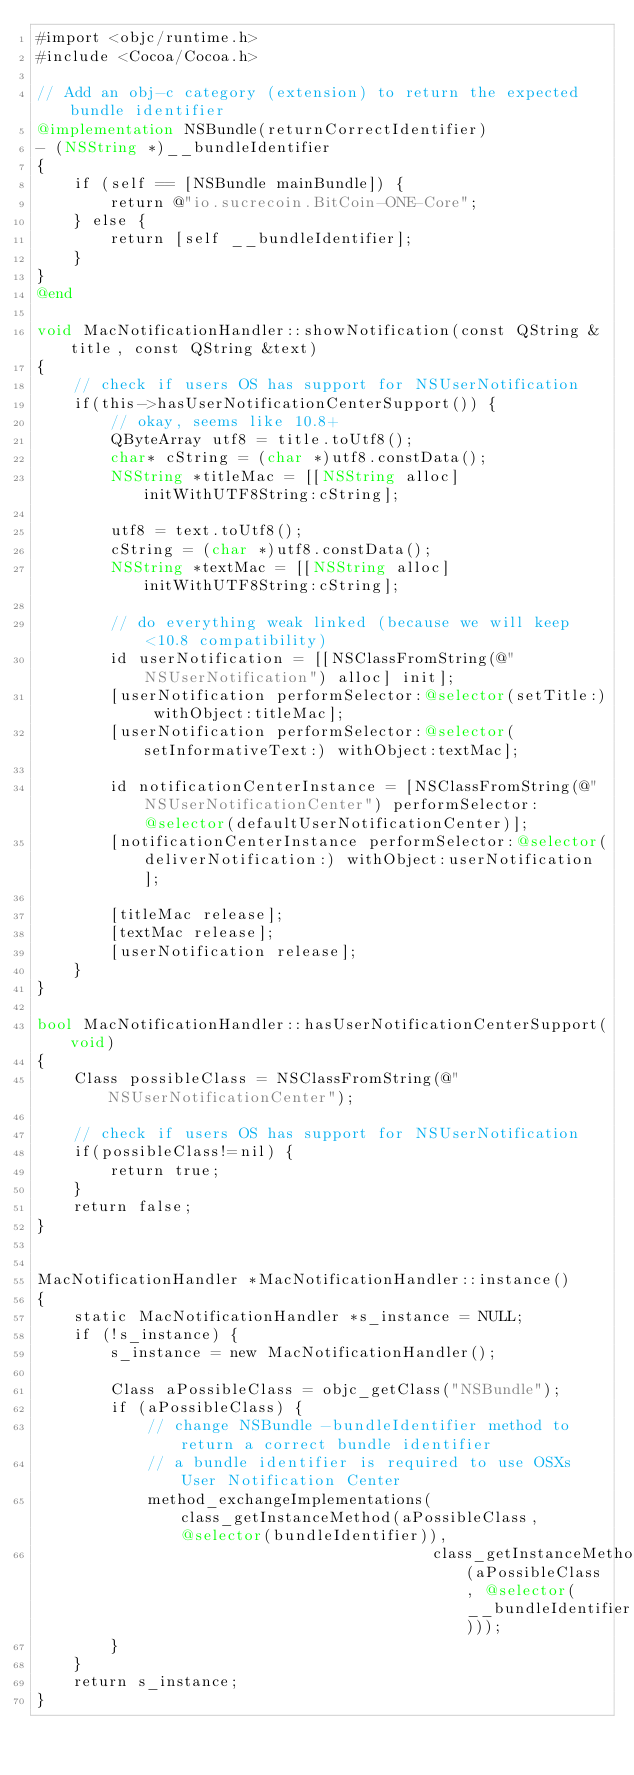<code> <loc_0><loc_0><loc_500><loc_500><_ObjectiveC_>#import <objc/runtime.h>
#include <Cocoa/Cocoa.h>

// Add an obj-c category (extension) to return the expected bundle identifier
@implementation NSBundle(returnCorrectIdentifier)
- (NSString *)__bundleIdentifier
{
    if (self == [NSBundle mainBundle]) {
        return @"io.sucrecoin.BitCoin-ONE-Core";
    } else {
        return [self __bundleIdentifier];
    }
}
@end

void MacNotificationHandler::showNotification(const QString &title, const QString &text)
{
    // check if users OS has support for NSUserNotification
    if(this->hasUserNotificationCenterSupport()) {
        // okay, seems like 10.8+
        QByteArray utf8 = title.toUtf8();
        char* cString = (char *)utf8.constData();
        NSString *titleMac = [[NSString alloc] initWithUTF8String:cString];

        utf8 = text.toUtf8();
        cString = (char *)utf8.constData();
        NSString *textMac = [[NSString alloc] initWithUTF8String:cString];

        // do everything weak linked (because we will keep <10.8 compatibility)
        id userNotification = [[NSClassFromString(@"NSUserNotification") alloc] init];
        [userNotification performSelector:@selector(setTitle:) withObject:titleMac];
        [userNotification performSelector:@selector(setInformativeText:) withObject:textMac];

        id notificationCenterInstance = [NSClassFromString(@"NSUserNotificationCenter") performSelector:@selector(defaultUserNotificationCenter)];
        [notificationCenterInstance performSelector:@selector(deliverNotification:) withObject:userNotification];

        [titleMac release];
        [textMac release];
        [userNotification release];
    }
}

bool MacNotificationHandler::hasUserNotificationCenterSupport(void)
{
    Class possibleClass = NSClassFromString(@"NSUserNotificationCenter");

    // check if users OS has support for NSUserNotification
    if(possibleClass!=nil) {
        return true;
    }
    return false;
}


MacNotificationHandler *MacNotificationHandler::instance()
{
    static MacNotificationHandler *s_instance = NULL;
    if (!s_instance) {
        s_instance = new MacNotificationHandler();
        
        Class aPossibleClass = objc_getClass("NSBundle");
        if (aPossibleClass) {
            // change NSBundle -bundleIdentifier method to return a correct bundle identifier
            // a bundle identifier is required to use OSXs User Notification Center
            method_exchangeImplementations(class_getInstanceMethod(aPossibleClass, @selector(bundleIdentifier)),
                                           class_getInstanceMethod(aPossibleClass, @selector(__bundleIdentifier)));
        }
    }
    return s_instance;
}
</code> 